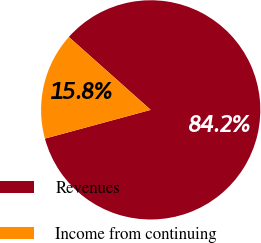<chart> <loc_0><loc_0><loc_500><loc_500><pie_chart><fcel>Revenues<fcel>Income from continuing<nl><fcel>84.2%<fcel>15.8%<nl></chart> 